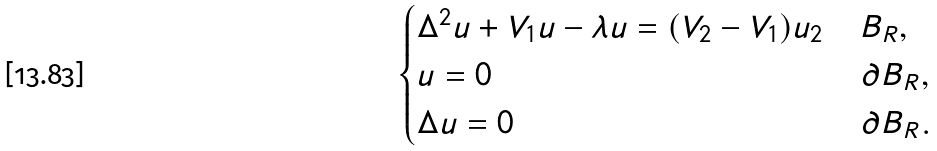Convert formula to latex. <formula><loc_0><loc_0><loc_500><loc_500>\begin{cases} \Delta ^ { 2 } u + V _ { 1 } u - \lambda u = ( V _ { 2 } - V _ { 1 } ) u _ { 2 } & \, B _ { R } , \\ u = 0 & \, \partial B _ { R } , \\ \Delta u = 0 & \, \partial B _ { R } . \end{cases}</formula> 